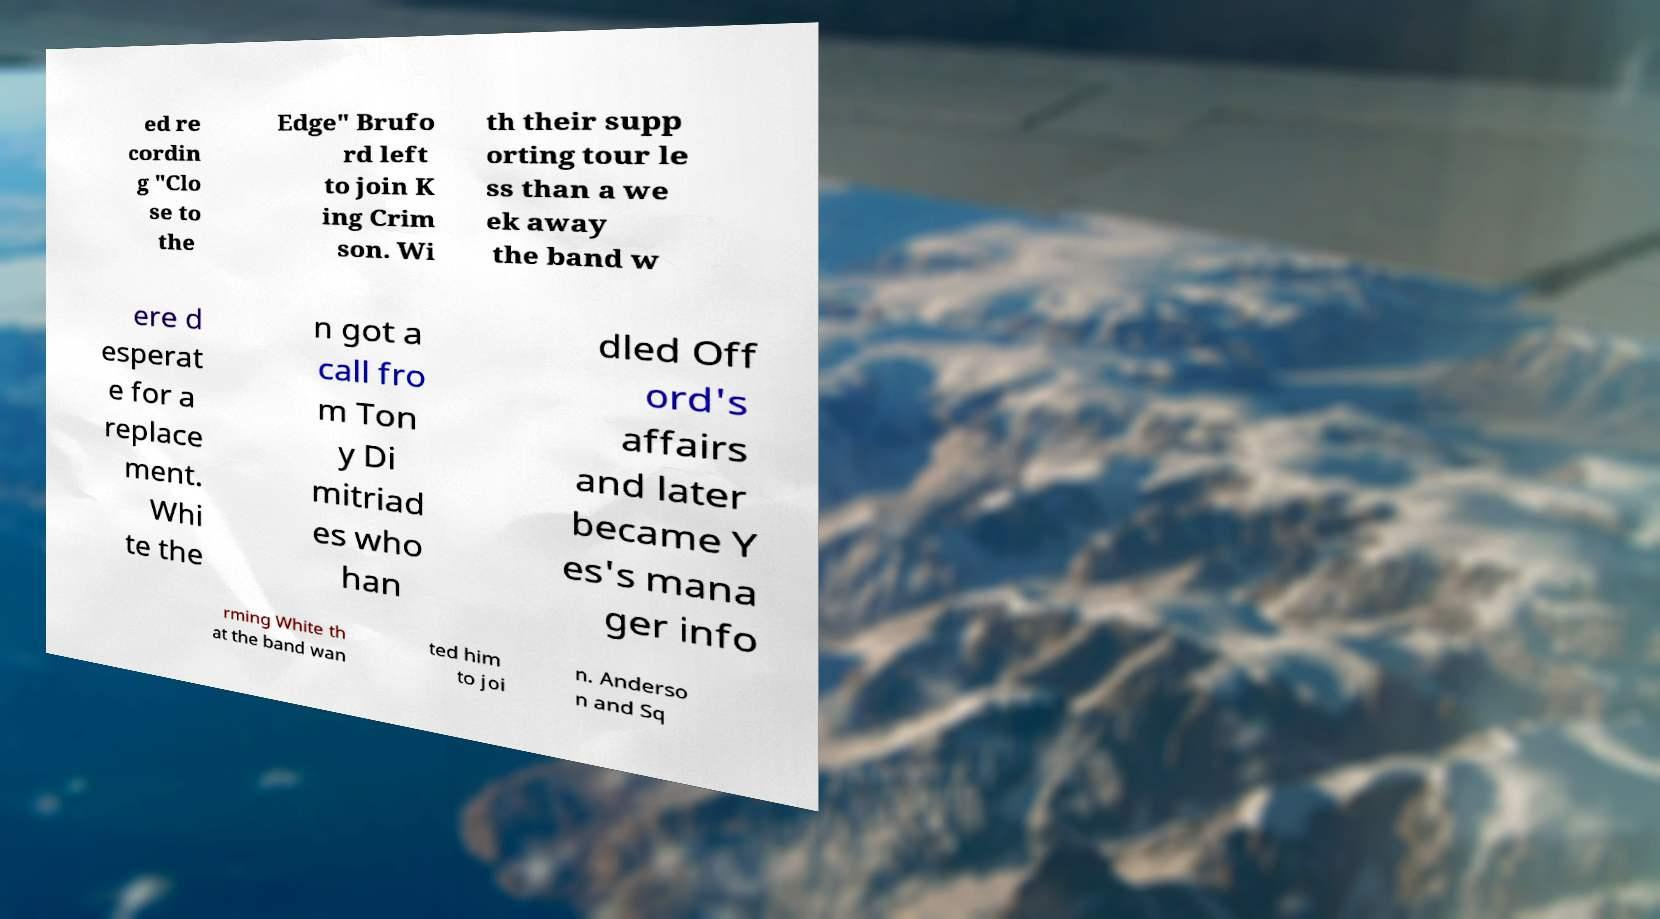I need the written content from this picture converted into text. Can you do that? ed re cordin g "Clo se to the Edge" Brufo rd left to join K ing Crim son. Wi th their supp orting tour le ss than a we ek away the band w ere d esperat e for a replace ment. Whi te the n got a call fro m Ton y Di mitriad es who han dled Off ord's affairs and later became Y es's mana ger info rming White th at the band wan ted him to joi n. Anderso n and Sq 